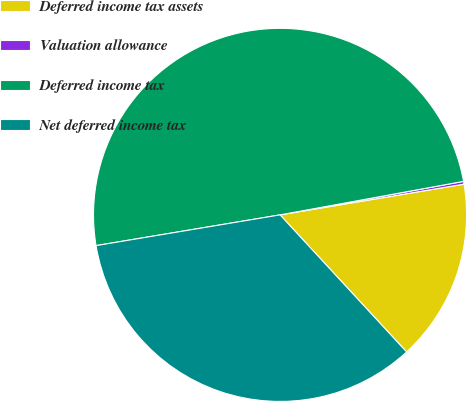Convert chart to OTSL. <chart><loc_0><loc_0><loc_500><loc_500><pie_chart><fcel>Deferred income tax assets<fcel>Valuation allowance<fcel>Deferred income tax<fcel>Net deferred income tax<nl><fcel>15.77%<fcel>0.24%<fcel>49.76%<fcel>34.23%<nl></chart> 